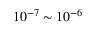<formula> <loc_0><loc_0><loc_500><loc_500>1 0 ^ { - 7 } \sim 1 0 ^ { - 6 }</formula> 